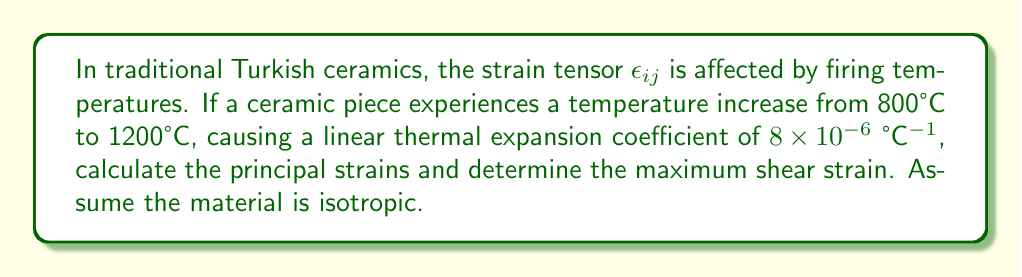Provide a solution to this math problem. Let's approach this step-by-step:

1) For an isotropic material undergoing thermal expansion, the strain tensor is given by:

   $$\epsilon_{ij} = \alpha \Delta T \delta_{ij}$$

   where $\alpha$ is the linear thermal expansion coefficient, $\Delta T$ is the temperature change, and $\delta_{ij}$ is the Kronecker delta.

2) Calculate $\Delta T$:
   $$\Delta T = 1200°C - 800°C = 400°C$$

3) The strain tensor becomes:

   $$\epsilon_{ij} = (8 \times 10^{-6})(400)\delta_{ij} = 3.2 \times 10^{-3}\delta_{ij}$$

4) This results in the following strain tensor:

   $$\epsilon_{ij} = \begin{pmatrix}
   3.2 \times 10^{-3} & 0 & 0 \\
   0 & 3.2 \times 10^{-3} & 0 \\
   0 & 0 & 3.2 \times 10^{-3}
   \end{pmatrix}$$

5) The principal strains are the diagonal elements of this tensor:

   $$\epsilon_1 = \epsilon_2 = \epsilon_3 = 3.2 \times 10^{-3}$$

6) The maximum shear strain is given by half the difference between the maximum and minimum principal strains:

   $$\gamma_{max} = \frac{1}{2}(\epsilon_{max} - \epsilon_{min}) = \frac{1}{2}(3.2 \times 10^{-3} - 3.2 \times 10^{-3}) = 0$$
Answer: Principal strains: $3.2 \times 10^{-3}$; Maximum shear strain: 0 